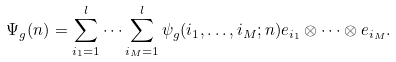Convert formula to latex. <formula><loc_0><loc_0><loc_500><loc_500>\Psi _ { g } ( n ) = \sum _ { i _ { 1 } = 1 } ^ { l } \dots \sum _ { i _ { M } = 1 } ^ { l } \psi _ { g } ( i _ { 1 } , \dots , i _ { M } ; n ) e _ { i _ { 1 } } \otimes \dots \otimes e _ { i _ { M } } .</formula> 